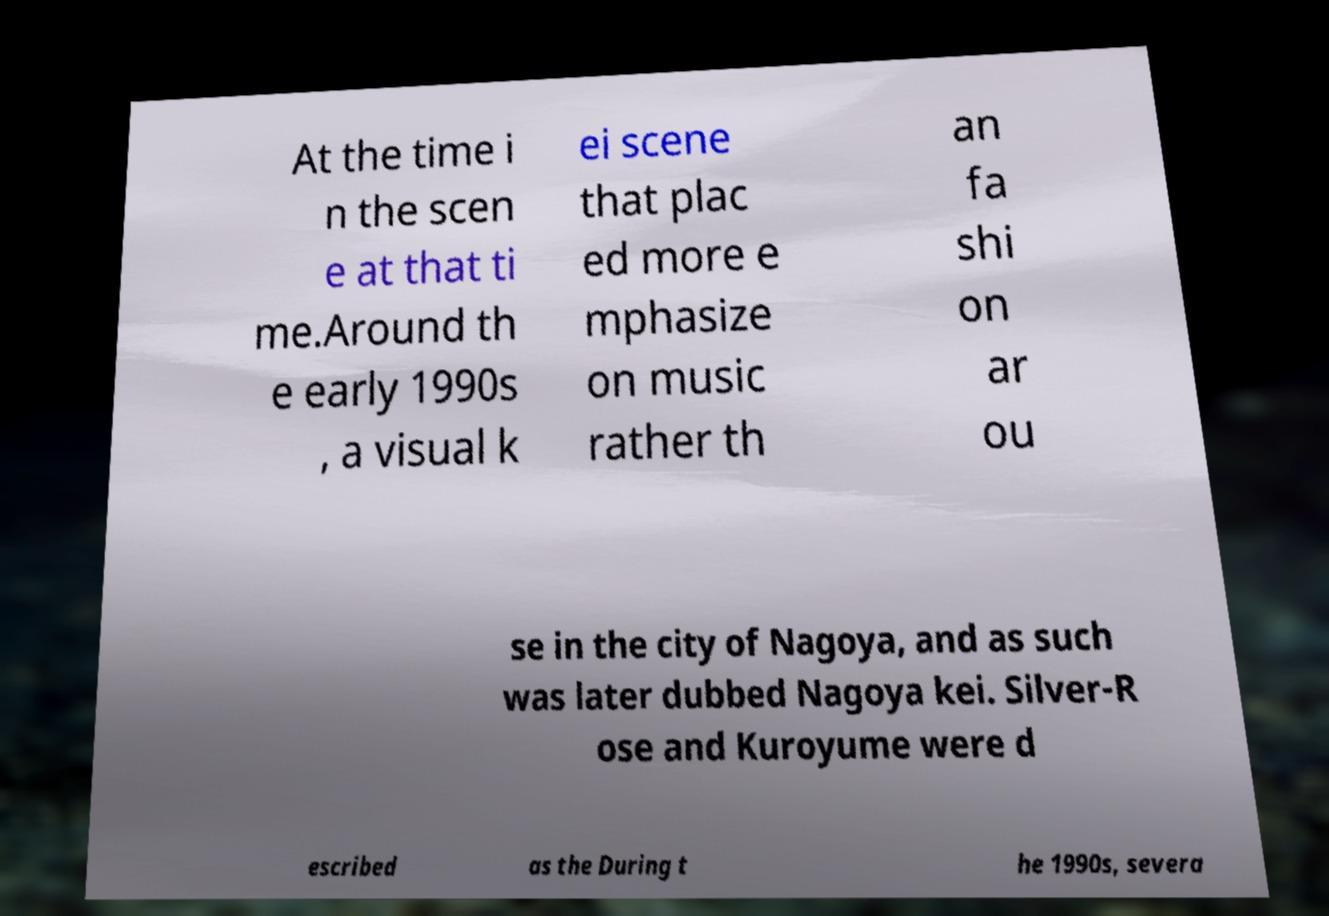I need the written content from this picture converted into text. Can you do that? At the time i n the scen e at that ti me.Around th e early 1990s , a visual k ei scene that plac ed more e mphasize on music rather th an fa shi on ar ou se in the city of Nagoya, and as such was later dubbed Nagoya kei. Silver-R ose and Kuroyume were d escribed as the During t he 1990s, severa 